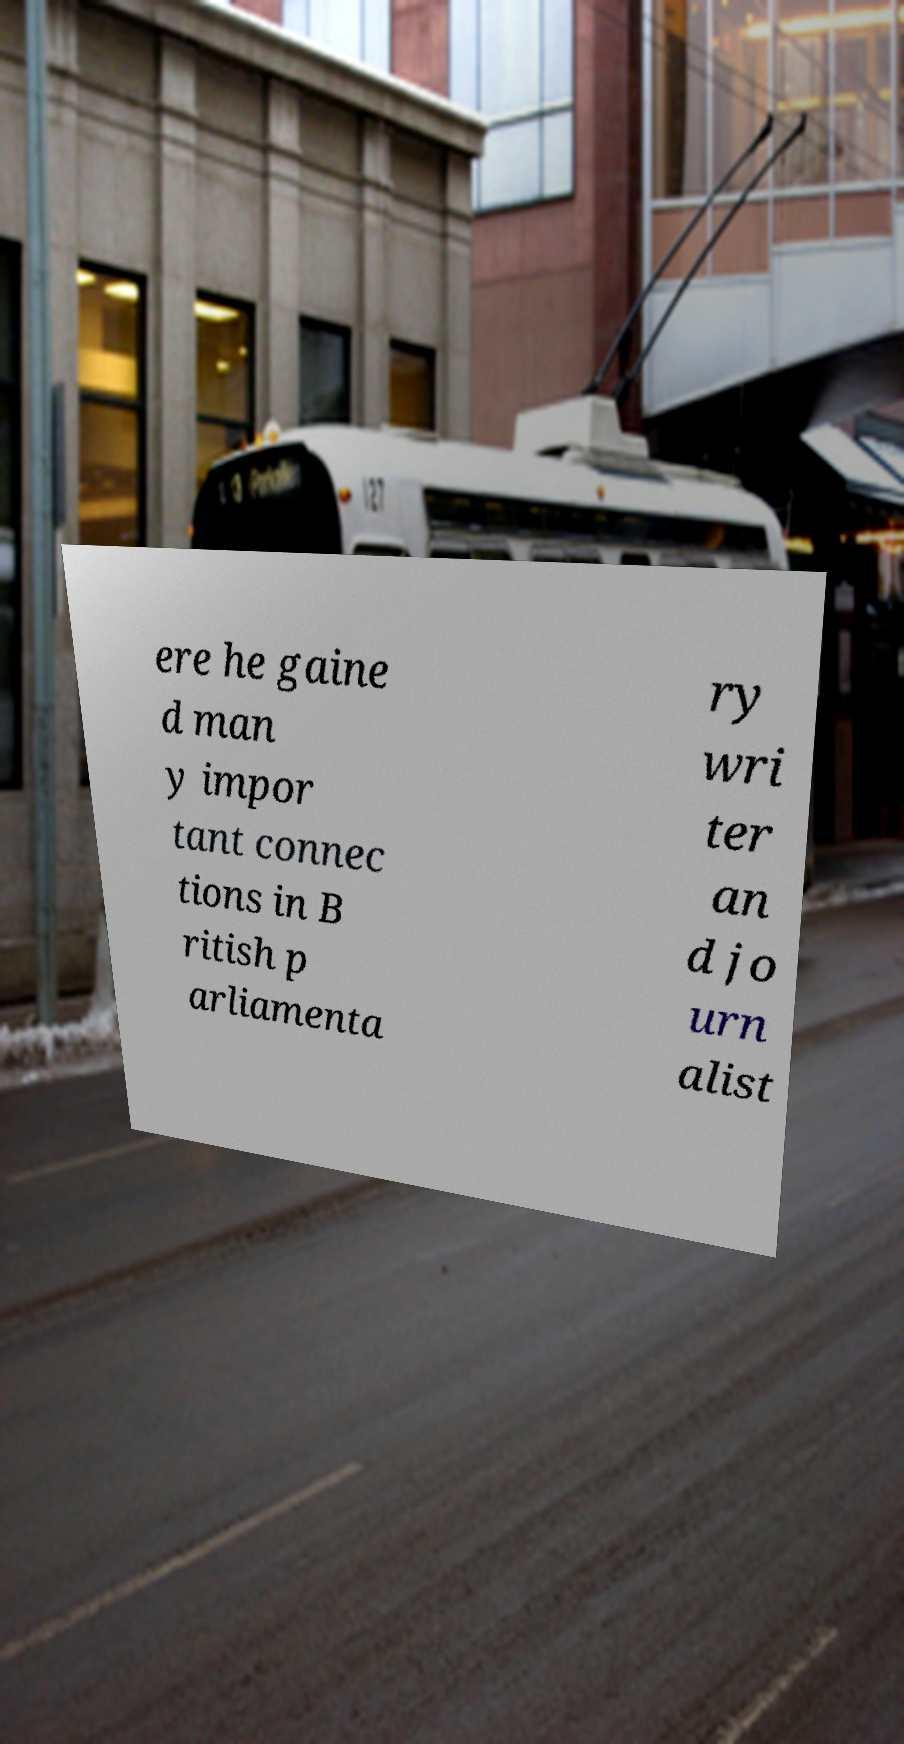For documentation purposes, I need the text within this image transcribed. Could you provide that? ere he gaine d man y impor tant connec tions in B ritish p arliamenta ry wri ter an d jo urn alist 